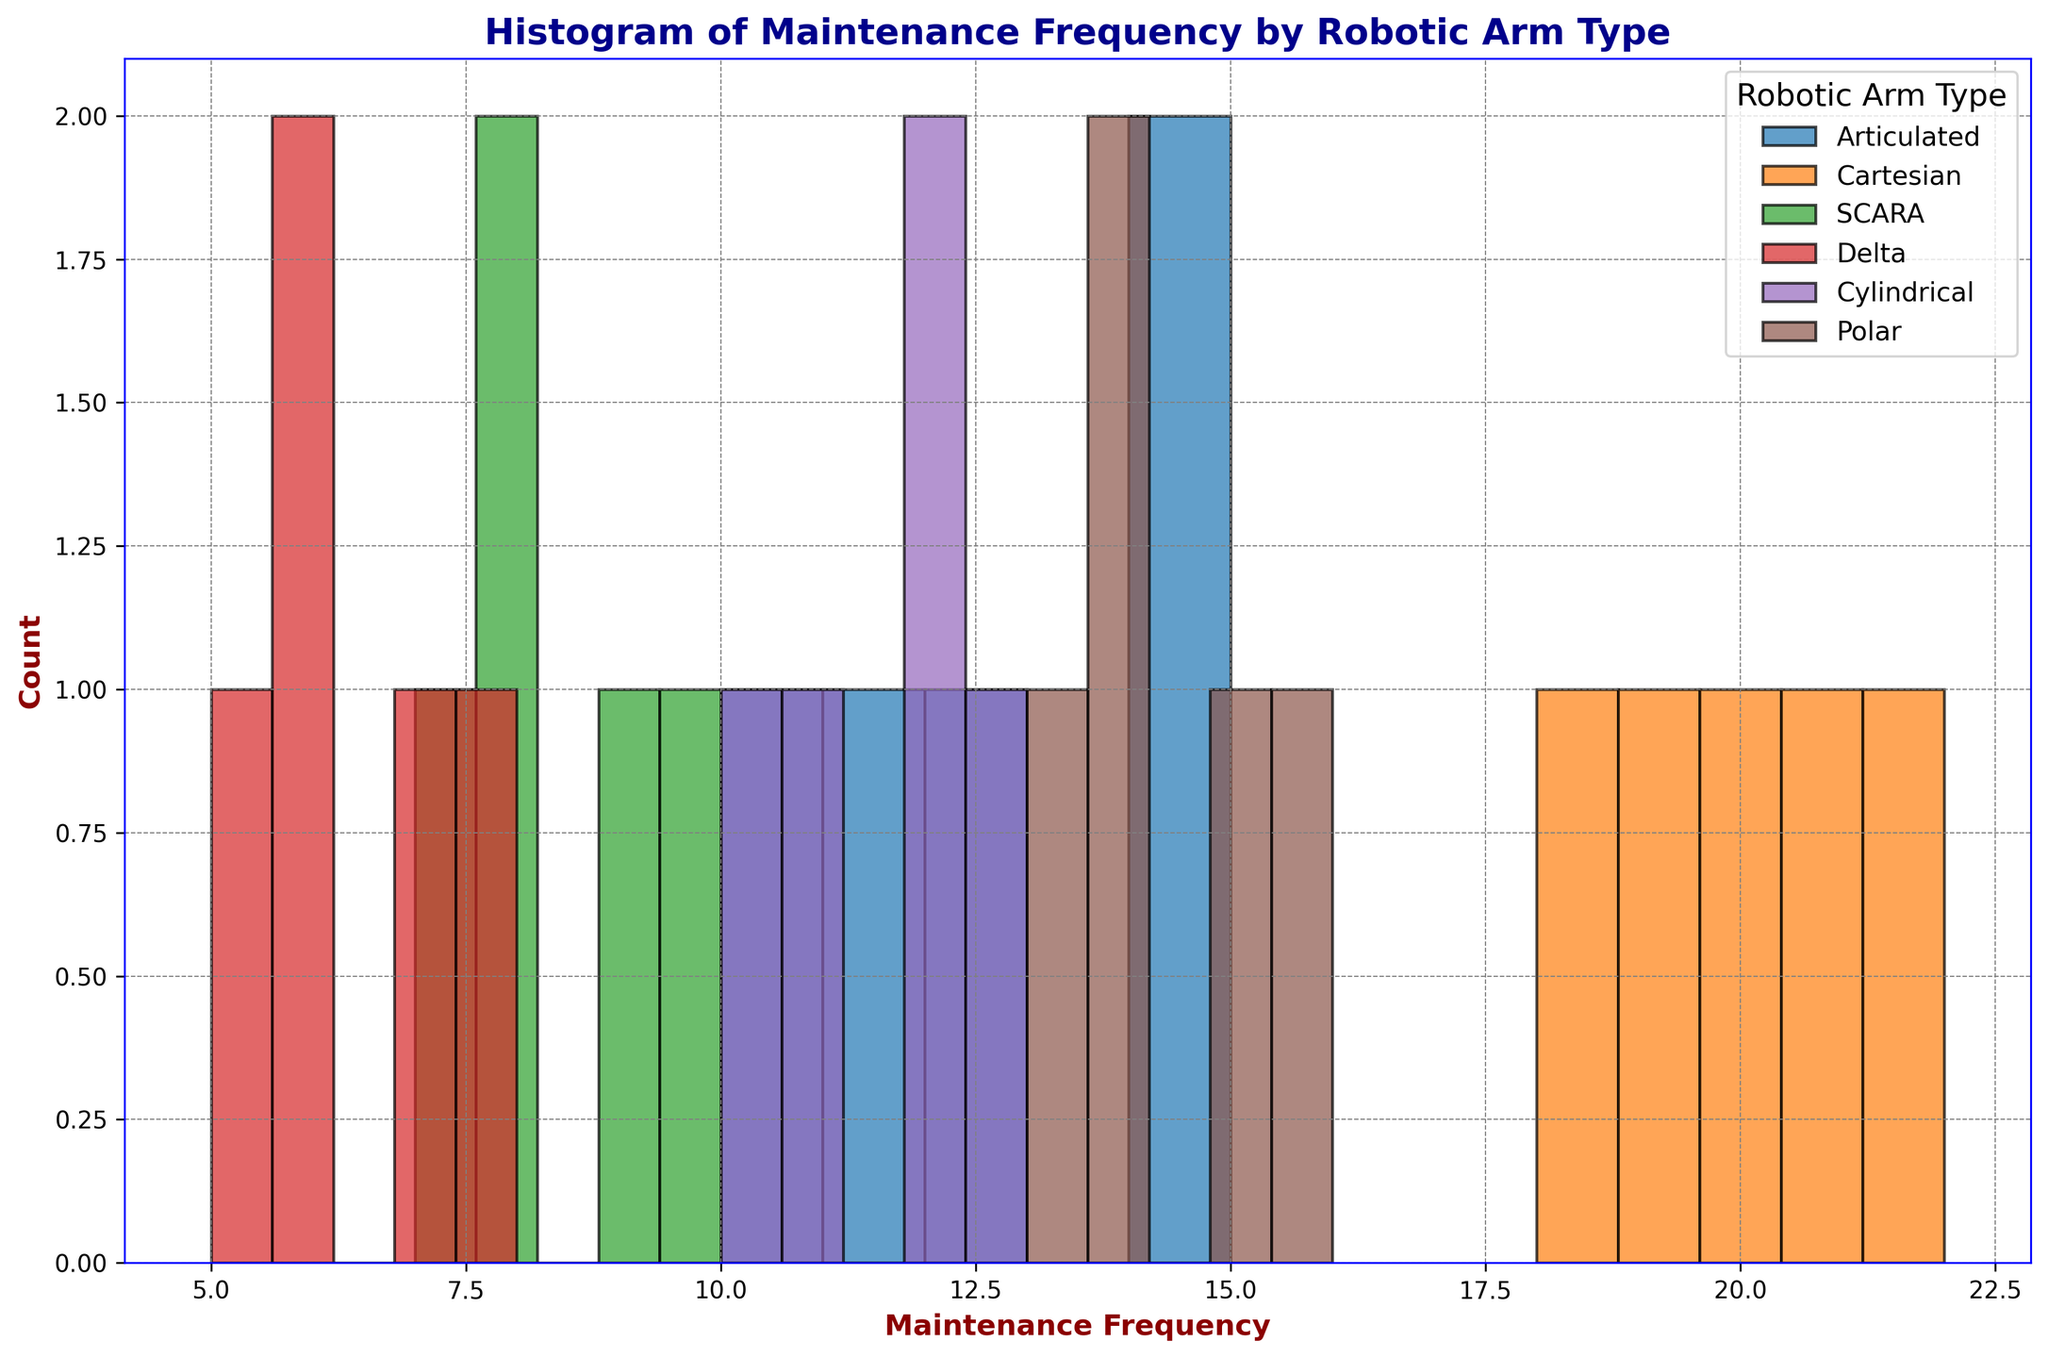What's the most common maintenance frequency for SCARA robotic arms? Looking at the histogram for SCARA robotic arms, the heights of the bars represent the count of each maintenance frequency. The tallest bar represents the most common frequency, which corresponds to 8.
Answer: 8 Which robotic arm type has the highest maintenance frequency recorded? By examining the histograms of all robotic arm types, we see that the Cartesian robotic arm has the highest maintenance frequency recorded, which is 22.
Answer: Cartesian How does the maintenance frequency of the SCARA robotic arm compare to the Delta one? By comparing the histograms of SCARA and Delta robotic arms, we see that SCARA's maintenance frequencies range from 7 to 10, while Delta's range from 5 to 8. SCARA generally requires maintenance more frequently.
Answer: SCARA generally requires more frequent maintenance than Delta Which robotic arm type shows the least variation in maintenance frequency? Variation can be inferred from the spread of the histogram. The Delta robotic arm has its frequencies clustered closely together (5 to 8), indicating the least variation.
Answer: Delta What is the range of maintenance frequencies for the Articulated robotic arm? The range of maintenance frequencies can be calculated by subtracting the minimum frequency from the maximum frequency within the Articulated category. The frequencies vary from 10 to 15, so the range is 15 - 10 = 5.
Answer: 5 How many different robotic arm types have a maintenance frequency of 12? To find this, count the histograms that include a bar over the x-axis value of 12. Articulated and Cylindrical both have maintenance frequencies that include 12.
Answer: 2 Which robotic arm types have a higher maximum maintenance frequency than the Polar robotic arm? First, identify the maximum maintenance frequency for Polar, which is 16. Then look for arm types with a maximum frequency higher than this. Cartesian has 22, which is higher than 16.
Answer: Cartesian What is the median maintenance frequency for the Polar robotic arm types? To find the median, list all the maintenance frequencies for Polar: 13, 14, 14, 15, 16. The median is the middle number in this sorted list, which is 14.
Answer: 14 When comparing the Articulated and Cylindrical robotic arms, which type shows a broader range of maintenance frequencies? Calculate the range for both: Articulated ranges from 10 to 15 (range = 5), and Cylindrical ranges from 10 to 13 (range = 3). Articulated has a broader range.
Answer: Articulated What is the mean maintenance frequency of the Cartesian robotic arms? Calculate the mean by summing the frequencies of Cartesian arms (20, 18, 22, 21, 19), which equals 100, and then dividing by 5 (number of data points). The mean is 100 / 5 = 20.
Answer: 20 